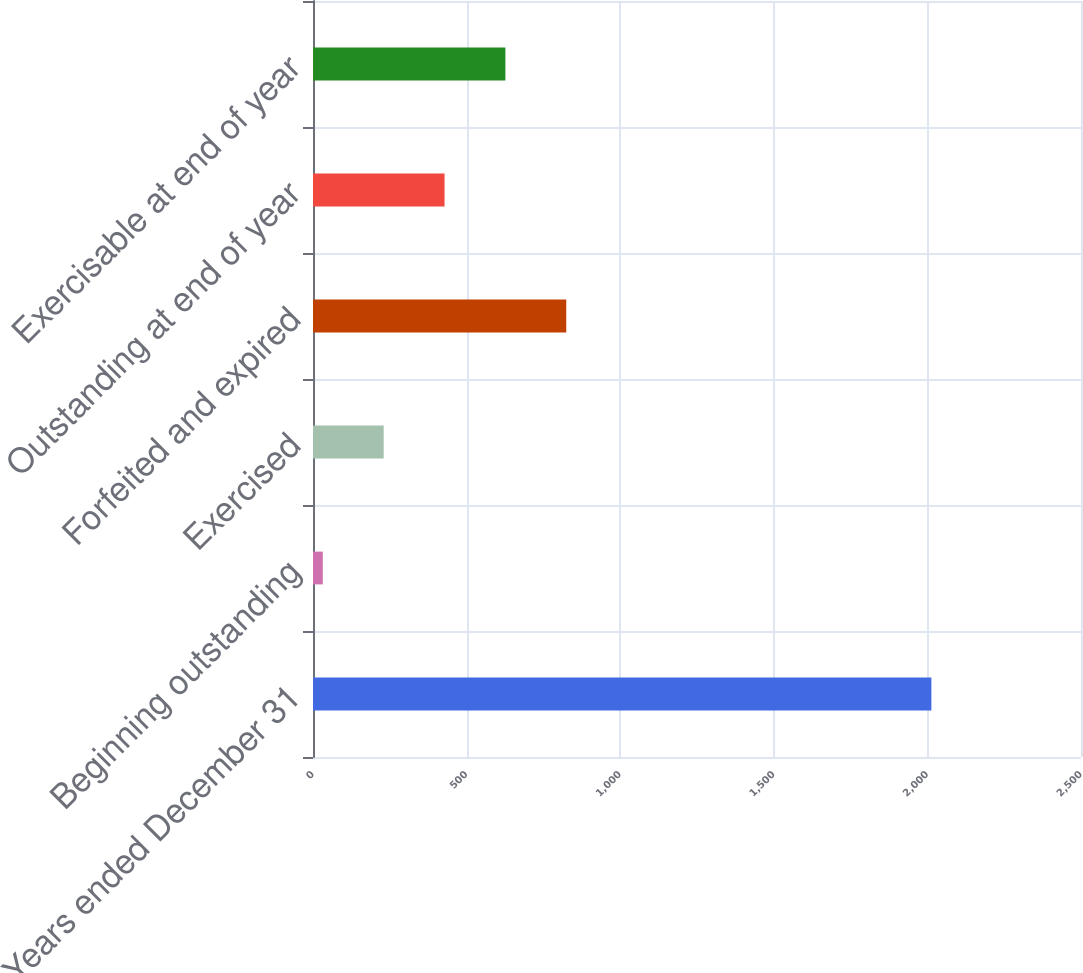Convert chart. <chart><loc_0><loc_0><loc_500><loc_500><bar_chart><fcel>Years ended December 31<fcel>Beginning outstanding<fcel>Exercised<fcel>Forfeited and expired<fcel>Outstanding at end of year<fcel>Exercisable at end of year<nl><fcel>2013<fcel>32<fcel>230.1<fcel>824.4<fcel>428.2<fcel>626.3<nl></chart> 